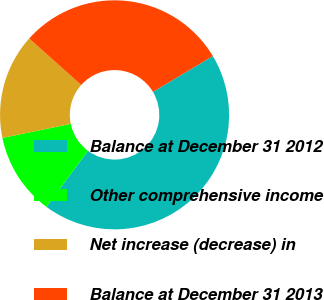Convert chart. <chart><loc_0><loc_0><loc_500><loc_500><pie_chart><fcel>Balance at December 31 2012<fcel>Other comprehensive income<fcel>Net increase (decrease) in<fcel>Balance at December 31 2013<nl><fcel>43.71%<fcel>11.63%<fcel>14.84%<fcel>29.81%<nl></chart> 